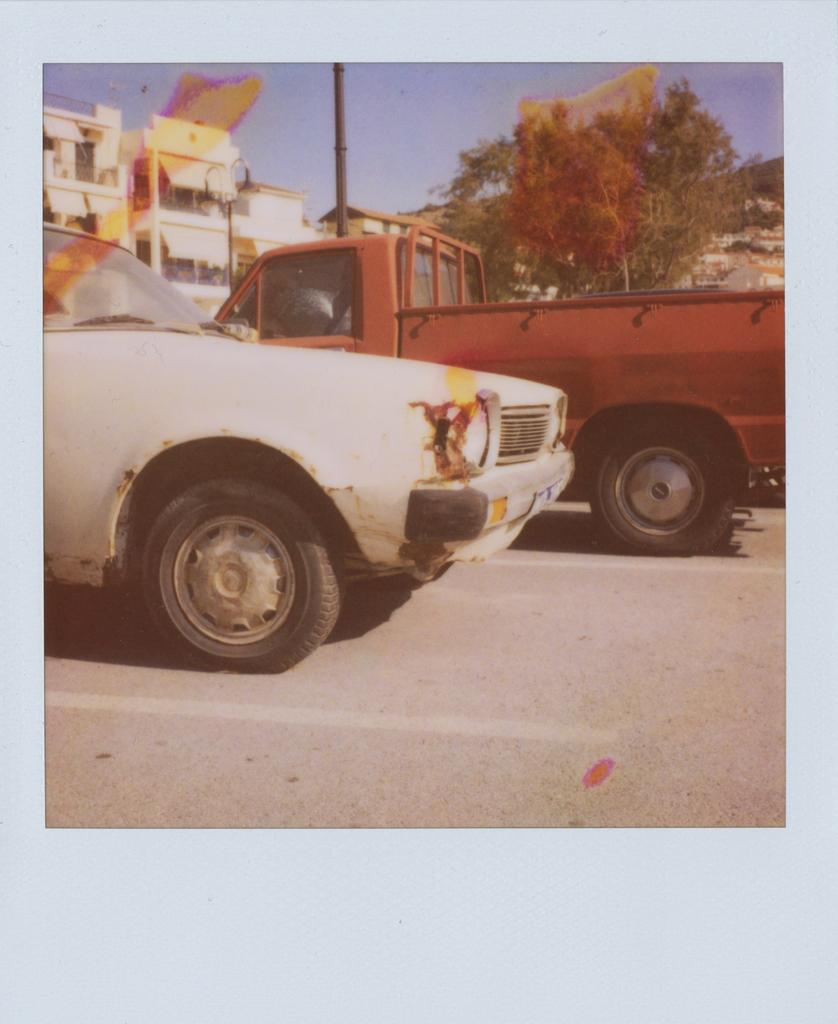What can be seen parked in the image? There are vehicles parked in the image. What type of natural elements are visible in the image? There are trees visible in the image. What type of structures can be seen in the background of the image? There are buildings in the background of the image. What object is present in the image that is typically used for supporting or holding something? There is a pole in the image. What color is the sky in the image? The sky is blue in the image. Can you tell me how many flowers are on the hair of the person in the image? There is no person with hair or flowers present in the image. What type of crush is visible in the image? There is no crush present in the image; the term "crush" does not apply to any of the objects or subjects in the image. 